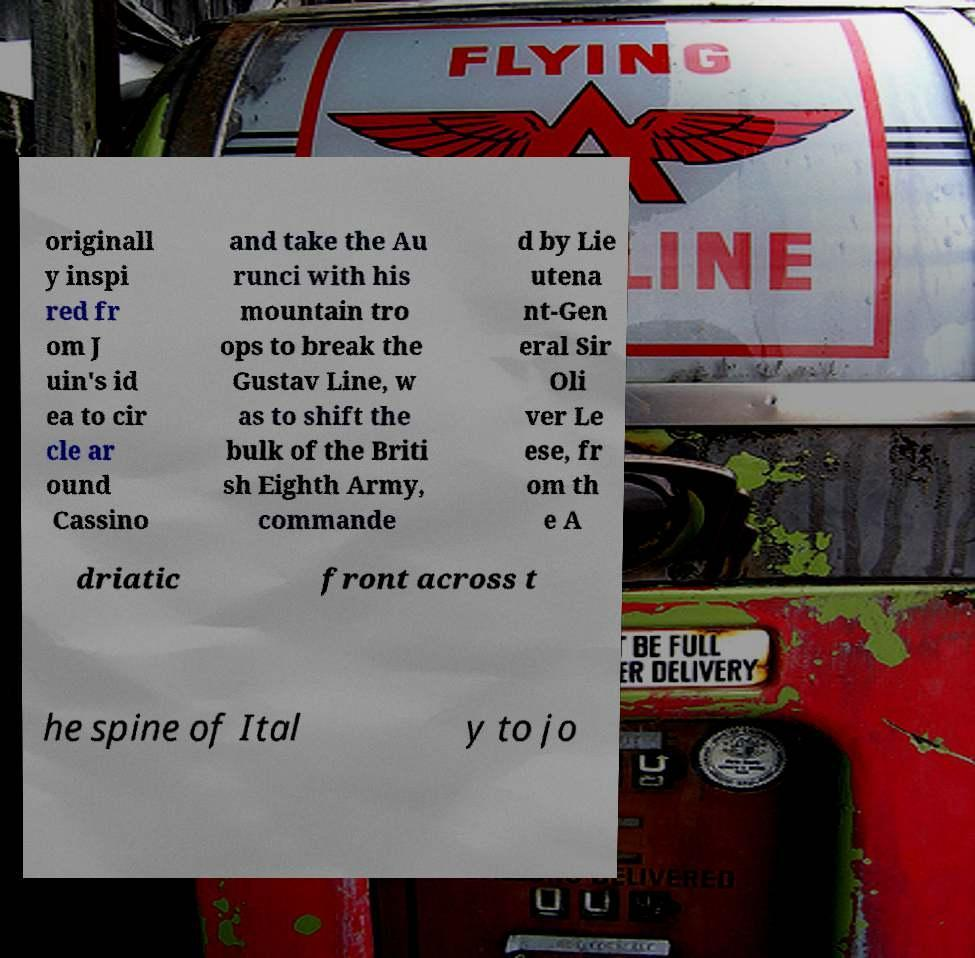Please identify and transcribe the text found in this image. originall y inspi red fr om J uin's id ea to cir cle ar ound Cassino and take the Au runci with his mountain tro ops to break the Gustav Line, w as to shift the bulk of the Briti sh Eighth Army, commande d by Lie utena nt-Gen eral Sir Oli ver Le ese, fr om th e A driatic front across t he spine of Ital y to jo 